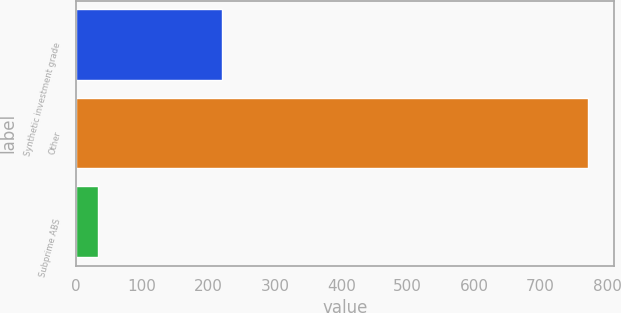Convert chart. <chart><loc_0><loc_0><loc_500><loc_500><bar_chart><fcel>Synthetic investment grade<fcel>Other<fcel>Subprime ABS<nl><fcel>220<fcel>772<fcel>33<nl></chart> 